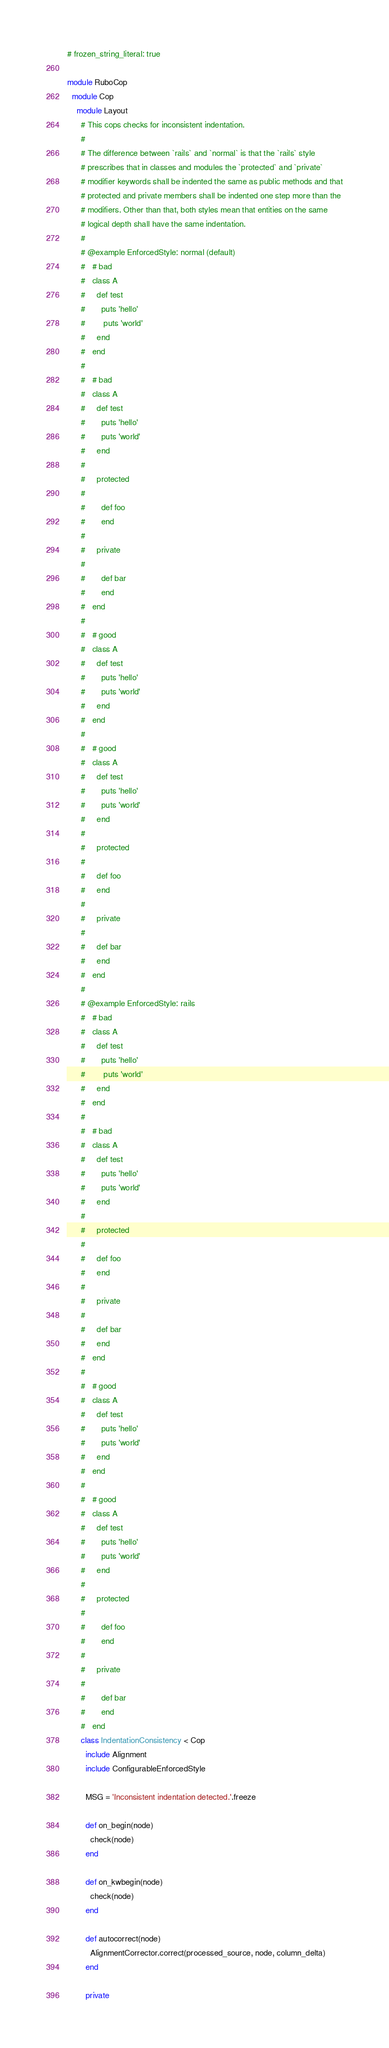Convert code to text. <code><loc_0><loc_0><loc_500><loc_500><_Ruby_># frozen_string_literal: true

module RuboCop
  module Cop
    module Layout
      # This cops checks for inconsistent indentation.
      #
      # The difference between `rails` and `normal` is that the `rails` style
      # prescribes that in classes and modules the `protected` and `private`
      # modifier keywords shall be indented the same as public methods and that
      # protected and private members shall be indented one step more than the
      # modifiers. Other than that, both styles mean that entities on the same
      # logical depth shall have the same indentation.
      #
      # @example EnforcedStyle: normal (default)
      #   # bad
      #   class A
      #     def test
      #       puts 'hello'
      #        puts 'world'
      #     end
      #   end
      #
      #   # bad
      #   class A
      #     def test
      #       puts 'hello'
      #       puts 'world'
      #     end
      #
      #     protected
      #
      #       def foo
      #       end
      #
      #     private
      #
      #       def bar
      #       end
      #   end
      #
      #   # good
      #   class A
      #     def test
      #       puts 'hello'
      #       puts 'world'
      #     end
      #   end
      #
      #   # good
      #   class A
      #     def test
      #       puts 'hello'
      #       puts 'world'
      #     end
      #
      #     protected
      #
      #     def foo
      #     end
      #
      #     private
      #
      #     def bar
      #     end
      #   end
      #
      # @example EnforcedStyle: rails
      #   # bad
      #   class A
      #     def test
      #       puts 'hello'
      #        puts 'world'
      #     end
      #   end
      #
      #   # bad
      #   class A
      #     def test
      #       puts 'hello'
      #       puts 'world'
      #     end
      #
      #     protected
      #
      #     def foo
      #     end
      #
      #     private
      #
      #     def bar
      #     end
      #   end
      #
      #   # good
      #   class A
      #     def test
      #       puts 'hello'
      #       puts 'world'
      #     end
      #   end
      #
      #   # good
      #   class A
      #     def test
      #       puts 'hello'
      #       puts 'world'
      #     end
      #
      #     protected
      #
      #       def foo
      #       end
      #
      #     private
      #
      #       def bar
      #       end
      #   end
      class IndentationConsistency < Cop
        include Alignment
        include ConfigurableEnforcedStyle

        MSG = 'Inconsistent indentation detected.'.freeze

        def on_begin(node)
          check(node)
        end

        def on_kwbegin(node)
          check(node)
        end

        def autocorrect(node)
          AlignmentCorrector.correct(processed_source, node, column_delta)
        end

        private
</code> 